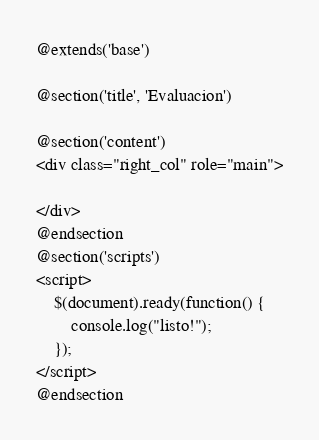Convert code to text. <code><loc_0><loc_0><loc_500><loc_500><_PHP_>
@extends('base')

@section('title', 'Evaluacion')

@section('content')
<div class="right_col" role="main">
    
</div>
@endsection
@section('scripts')
<script>
    $(document).ready(function() {
        console.log("listo!");
    });
</script>
@endsection</code> 